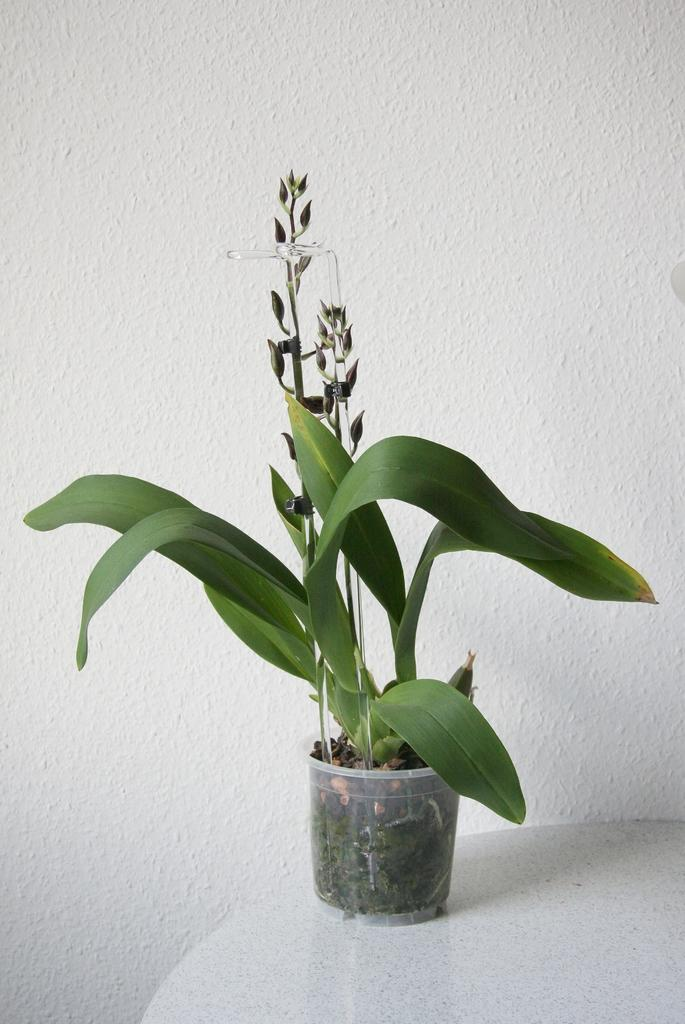What type of plant is in the container in the image? The facts do not specify the type of plant in the container. Where is the plant located in the image? The plant is placed on a surface in the image. What can be seen behind the plant in the image? There is a wall visible in the image. How many oranges are hanging from the arm in the image? There is no arm or oranges present in the image. 